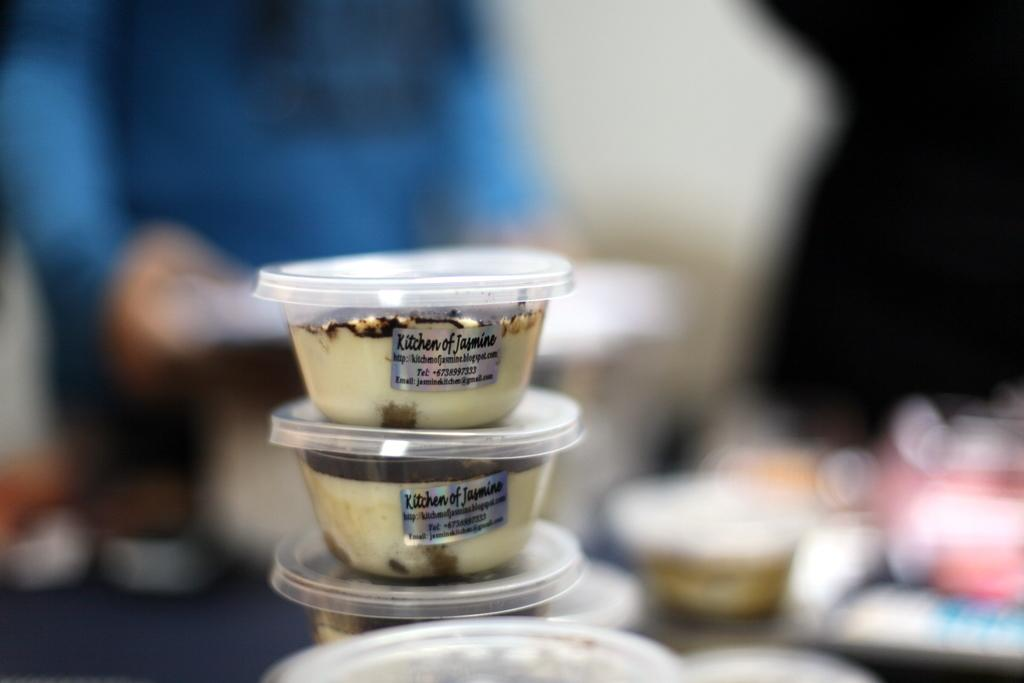What type of food is depicted in the image? The image contains ice cream cups. How are the ice cream cups arranged in the image? The ice cream cups are arranged one above the other in the center of the image. What type of market can be seen in the background of the image? There is no market present in the image; it only features ice cream cups arranged one above the other. How does the crow interact with the ice cream cups in the image? There is no crow present in the image, so it cannot interact with the ice cream cups. 